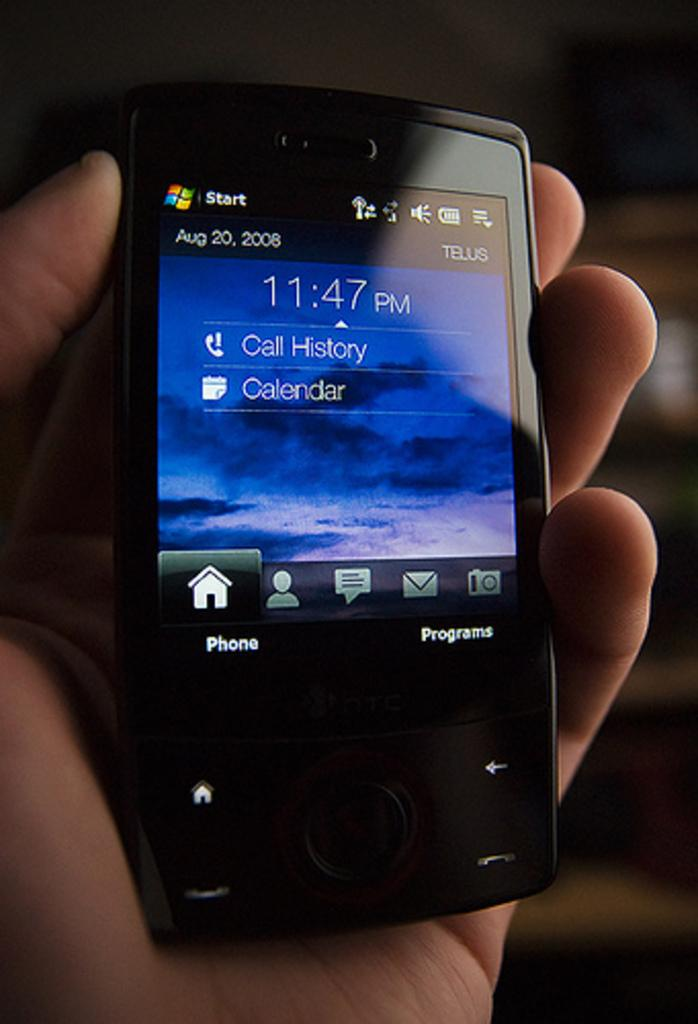<image>
Give a short and clear explanation of the subsequent image. A phone display screen shows the time of 11:47 PM, and sections for Calendar and Call History. 